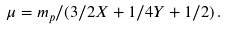<formula> <loc_0><loc_0><loc_500><loc_500>\mu = m _ { p } / ( 3 / 2 X + 1 / 4 Y + 1 / 2 ) \, .</formula> 